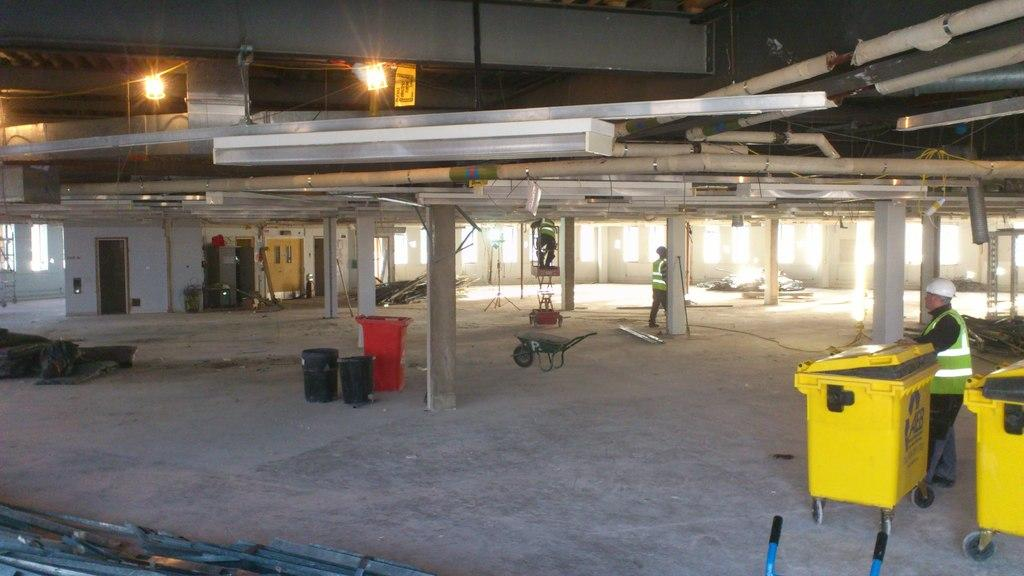What type of structure is visible in the image? There is a building in the image. How many people can be seen in the image? There are three persons in the image. What objects are present for waste disposal in the image? There are bins in the image. What type of vehicle is visible in the image? There is a cart in the image. What can be seen providing illumination in the image? There are lights in the image. What architectural feature supports the building in the image? There are pillars in the image. What feature allows access to the building in the image? There is a door in the image. What word is being spelled out by the kittens in the image? There are no kittens present in the image, so no word can be spelled out by them. What nation is represented by the flag in the image? There is no flag present in the image, so it is not possible to determine which nation it might represent. 